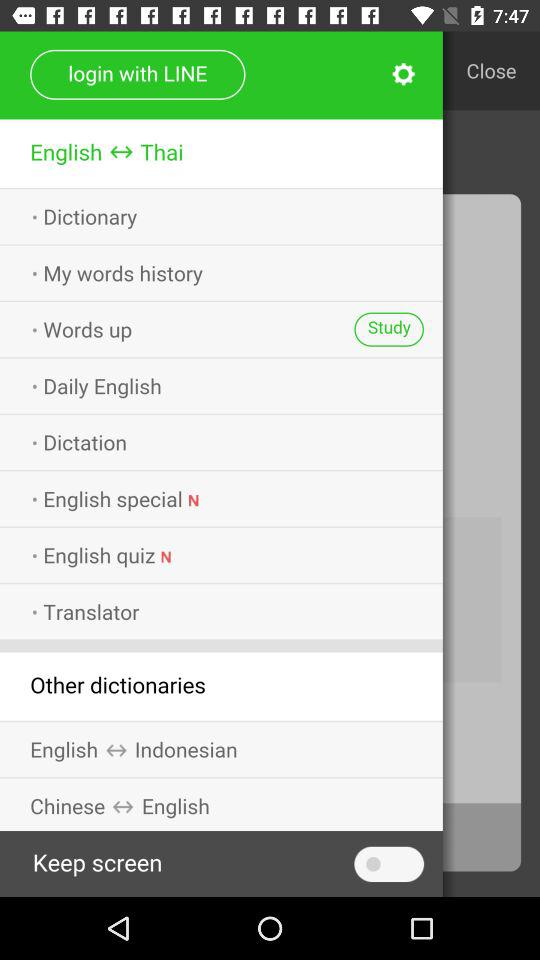What app can we use to log in? You can use "LINE" app to log in. 